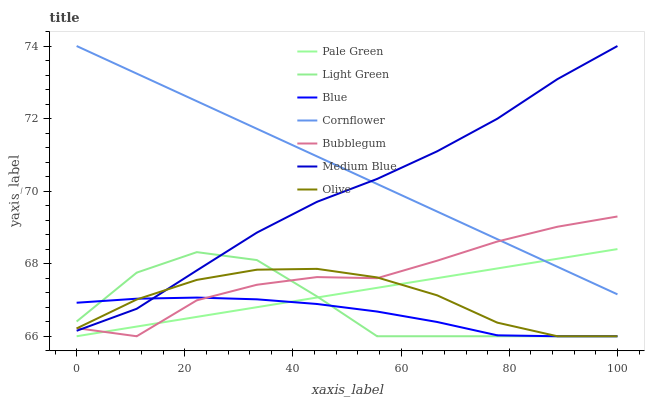Does Blue have the minimum area under the curve?
Answer yes or no. Yes. Does Cornflower have the maximum area under the curve?
Answer yes or no. Yes. Does Medium Blue have the minimum area under the curve?
Answer yes or no. No. Does Medium Blue have the maximum area under the curve?
Answer yes or no. No. Is Pale Green the smoothest?
Answer yes or no. Yes. Is Light Green the roughest?
Answer yes or no. Yes. Is Cornflower the smoothest?
Answer yes or no. No. Is Cornflower the roughest?
Answer yes or no. No. Does Blue have the lowest value?
Answer yes or no. Yes. Does Medium Blue have the lowest value?
Answer yes or no. No. Does Medium Blue have the highest value?
Answer yes or no. Yes. Does Bubblegum have the highest value?
Answer yes or no. No. Is Olive less than Cornflower?
Answer yes or no. Yes. Is Cornflower greater than Blue?
Answer yes or no. Yes. Does Cornflower intersect Pale Green?
Answer yes or no. Yes. Is Cornflower less than Pale Green?
Answer yes or no. No. Is Cornflower greater than Pale Green?
Answer yes or no. No. Does Olive intersect Cornflower?
Answer yes or no. No. 